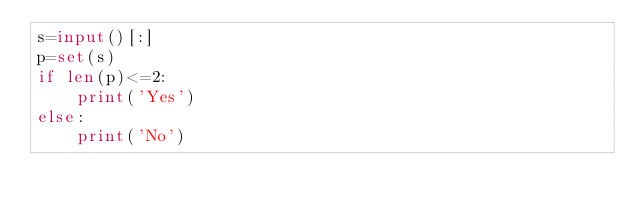Convert code to text. <code><loc_0><loc_0><loc_500><loc_500><_Python_>s=input()[:]
p=set(s)
if len(p)<=2:
    print('Yes')
else:
    print('No')
</code> 